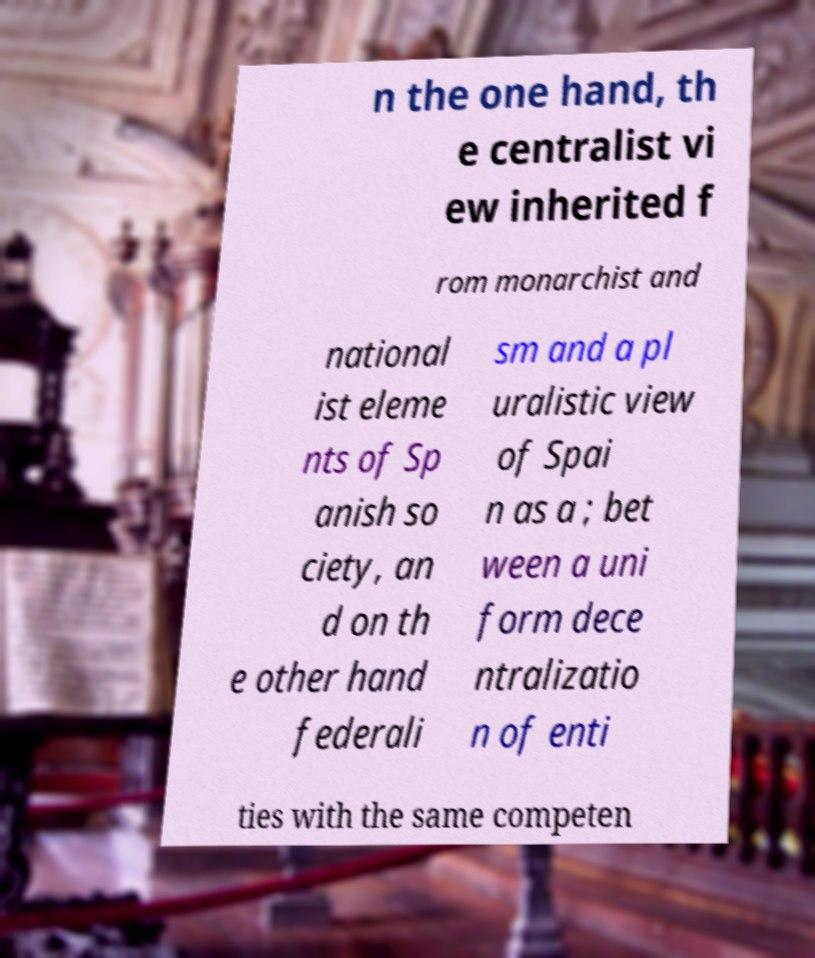Please read and relay the text visible in this image. What does it say? n the one hand, th e centralist vi ew inherited f rom monarchist and national ist eleme nts of Sp anish so ciety, an d on th e other hand federali sm and a pl uralistic view of Spai n as a ; bet ween a uni form dece ntralizatio n of enti ties with the same competen 